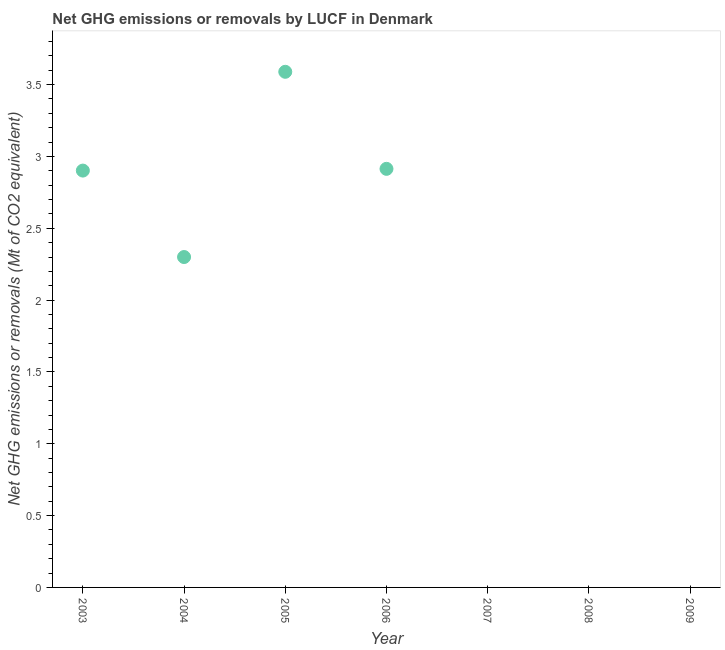What is the ghg net emissions or removals in 2009?
Ensure brevity in your answer.  0. Across all years, what is the maximum ghg net emissions or removals?
Your answer should be very brief. 3.59. Across all years, what is the minimum ghg net emissions or removals?
Ensure brevity in your answer.  0. What is the sum of the ghg net emissions or removals?
Your answer should be compact. 11.7. What is the difference between the ghg net emissions or removals in 2003 and 2004?
Your response must be concise. 0.6. What is the average ghg net emissions or removals per year?
Provide a short and direct response. 1.67. What is the median ghg net emissions or removals?
Ensure brevity in your answer.  2.3. In how many years, is the ghg net emissions or removals greater than 2.3 Mt?
Provide a succinct answer. 3. What is the ratio of the ghg net emissions or removals in 2004 to that in 2006?
Your answer should be compact. 0.79. What is the difference between the highest and the second highest ghg net emissions or removals?
Provide a short and direct response. 0.68. What is the difference between the highest and the lowest ghg net emissions or removals?
Your answer should be very brief. 3.59. How many dotlines are there?
Keep it short and to the point. 1. Does the graph contain any zero values?
Your response must be concise. Yes. What is the title of the graph?
Your response must be concise. Net GHG emissions or removals by LUCF in Denmark. What is the label or title of the X-axis?
Your answer should be compact. Year. What is the label or title of the Y-axis?
Provide a succinct answer. Net GHG emissions or removals (Mt of CO2 equivalent). What is the Net GHG emissions or removals (Mt of CO2 equivalent) in 2003?
Provide a succinct answer. 2.9. What is the Net GHG emissions or removals (Mt of CO2 equivalent) in 2004?
Your answer should be very brief. 2.3. What is the Net GHG emissions or removals (Mt of CO2 equivalent) in 2005?
Provide a short and direct response. 3.59. What is the Net GHG emissions or removals (Mt of CO2 equivalent) in 2006?
Give a very brief answer. 2.91. What is the Net GHG emissions or removals (Mt of CO2 equivalent) in 2007?
Offer a very short reply. 0. What is the Net GHG emissions or removals (Mt of CO2 equivalent) in 2008?
Your response must be concise. 0. What is the Net GHG emissions or removals (Mt of CO2 equivalent) in 2009?
Keep it short and to the point. 0. What is the difference between the Net GHG emissions or removals (Mt of CO2 equivalent) in 2003 and 2004?
Ensure brevity in your answer.  0.6. What is the difference between the Net GHG emissions or removals (Mt of CO2 equivalent) in 2003 and 2005?
Provide a succinct answer. -0.69. What is the difference between the Net GHG emissions or removals (Mt of CO2 equivalent) in 2003 and 2006?
Your answer should be very brief. -0.01. What is the difference between the Net GHG emissions or removals (Mt of CO2 equivalent) in 2004 and 2005?
Your response must be concise. -1.29. What is the difference between the Net GHG emissions or removals (Mt of CO2 equivalent) in 2004 and 2006?
Make the answer very short. -0.61. What is the difference between the Net GHG emissions or removals (Mt of CO2 equivalent) in 2005 and 2006?
Make the answer very short. 0.68. What is the ratio of the Net GHG emissions or removals (Mt of CO2 equivalent) in 2003 to that in 2004?
Offer a terse response. 1.26. What is the ratio of the Net GHG emissions or removals (Mt of CO2 equivalent) in 2003 to that in 2005?
Make the answer very short. 0.81. What is the ratio of the Net GHG emissions or removals (Mt of CO2 equivalent) in 2003 to that in 2006?
Provide a short and direct response. 1. What is the ratio of the Net GHG emissions or removals (Mt of CO2 equivalent) in 2004 to that in 2005?
Make the answer very short. 0.64. What is the ratio of the Net GHG emissions or removals (Mt of CO2 equivalent) in 2004 to that in 2006?
Keep it short and to the point. 0.79. What is the ratio of the Net GHG emissions or removals (Mt of CO2 equivalent) in 2005 to that in 2006?
Provide a succinct answer. 1.23. 